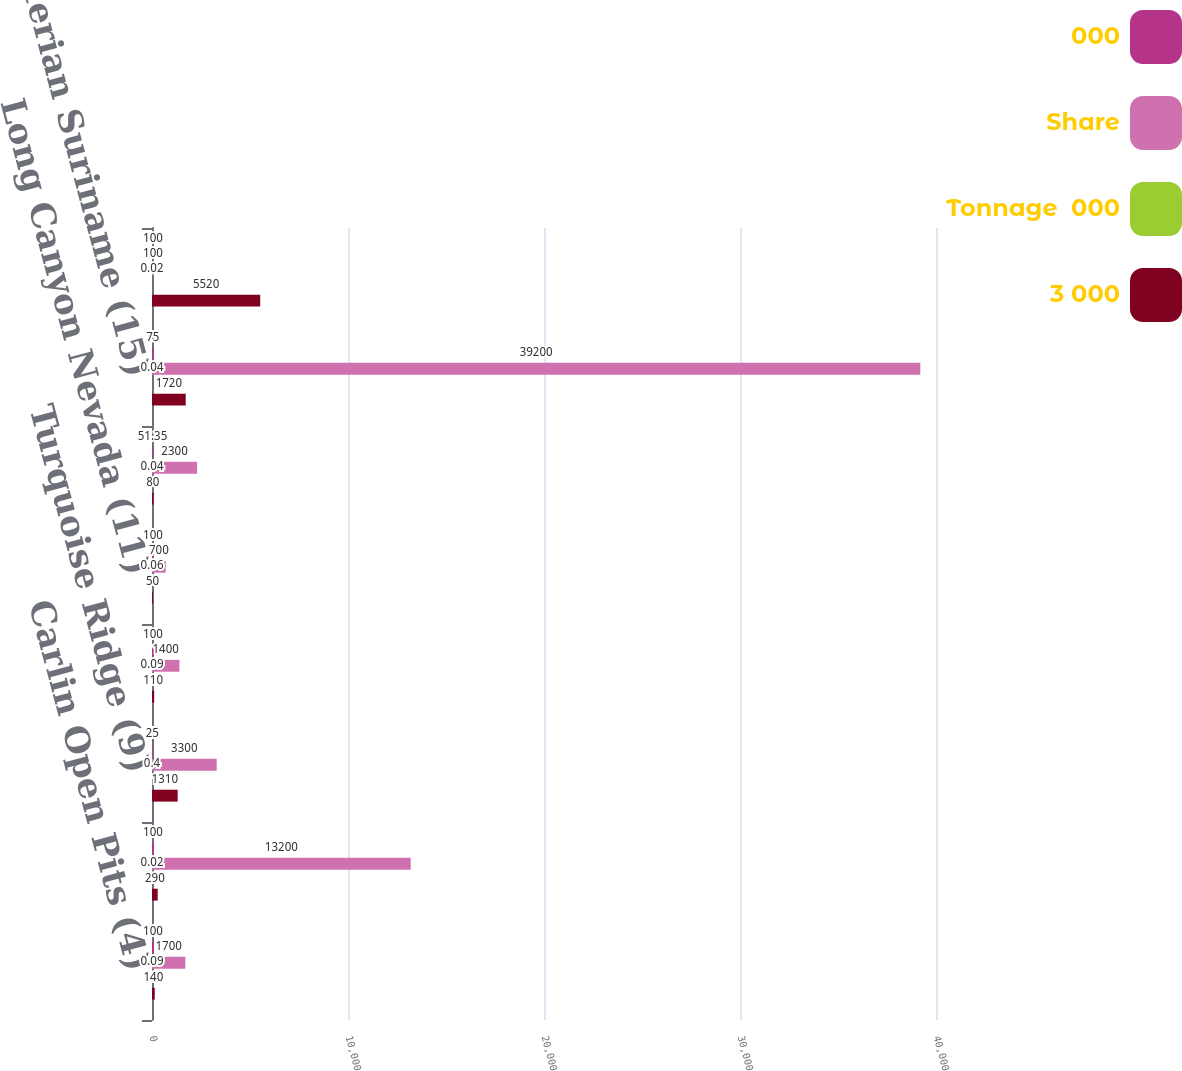Convert chart. <chart><loc_0><loc_0><loc_500><loc_500><stacked_bar_chart><ecel><fcel>Carlin Open Pits (4)<fcel>Phoenix (8)<fcel>Turquoise Ridge (9)<fcel>Twin Creeks (10)<fcel>Long Canyon Nevada (11)<fcel>Yanacocha Stockpiles (6)<fcel>Merian Suriname (15)<fcel>Boddington Open Pit (16)<nl><fcel>000<fcel>100<fcel>100<fcel>25<fcel>100<fcel>100<fcel>51.35<fcel>75<fcel>100<nl><fcel>Share<fcel>1700<fcel>13200<fcel>3300<fcel>1400<fcel>700<fcel>2300<fcel>39200<fcel>100<nl><fcel>Tonnage  000<fcel>0.09<fcel>0.02<fcel>0.4<fcel>0.09<fcel>0.06<fcel>0.04<fcel>0.04<fcel>0.02<nl><fcel>3 000<fcel>140<fcel>290<fcel>1310<fcel>110<fcel>50<fcel>80<fcel>1720<fcel>5520<nl></chart> 